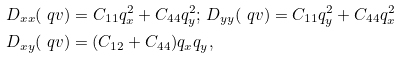<formula> <loc_0><loc_0><loc_500><loc_500>& D _ { x x } ( \ q v ) = C _ { 1 1 } q _ { x } ^ { 2 } + C _ { 4 4 } q _ { y } ^ { 2 } ; \, D _ { y y } ( \ q v ) = C _ { 1 1 } q _ { y } ^ { 2 } + C _ { 4 4 } q _ { x } ^ { 2 } \\ & D _ { x y } ( \ q v ) = ( C _ { 1 2 } + C _ { 4 4 } ) q _ { x } q _ { y } ,</formula> 